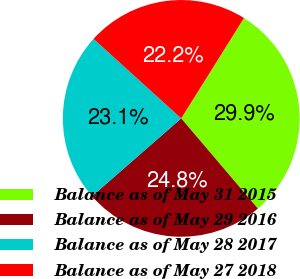Convert chart to OTSL. <chart><loc_0><loc_0><loc_500><loc_500><pie_chart><fcel>Balance as of May 31 2015<fcel>Balance as of May 29 2016<fcel>Balance as of May 28 2017<fcel>Balance as of May 27 2018<nl><fcel>29.89%<fcel>24.79%<fcel>23.14%<fcel>22.17%<nl></chart> 